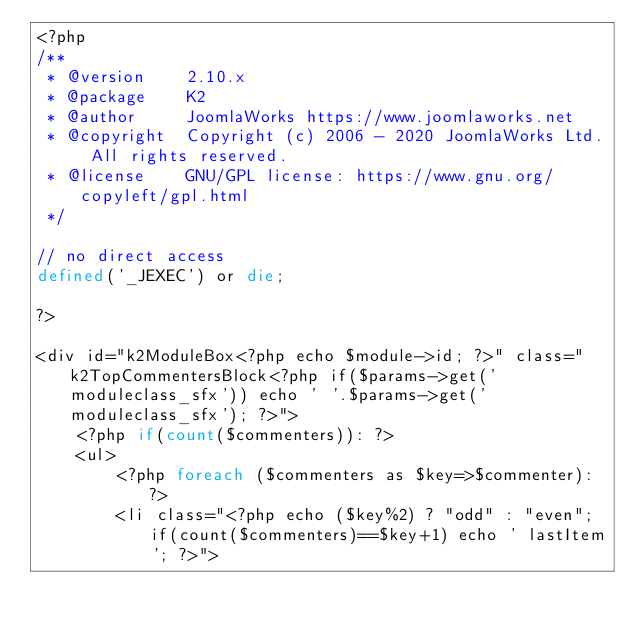<code> <loc_0><loc_0><loc_500><loc_500><_PHP_><?php
/**
 * @version    2.10.x
 * @package    K2
 * @author     JoomlaWorks https://www.joomlaworks.net
 * @copyright  Copyright (c) 2006 - 2020 JoomlaWorks Ltd. All rights reserved.
 * @license    GNU/GPL license: https://www.gnu.org/copyleft/gpl.html
 */

// no direct access
defined('_JEXEC') or die;

?>

<div id="k2ModuleBox<?php echo $module->id; ?>" class="k2TopCommentersBlock<?php if($params->get('moduleclass_sfx')) echo ' '.$params->get('moduleclass_sfx'); ?>">
    <?php if(count($commenters)): ?>
    <ul>
        <?php foreach ($commenters as $key=>$commenter): ?>
        <li class="<?php echo ($key%2) ? "odd" : "even"; if(count($commenters)==$key+1) echo ' lastItem'; ?>"></code> 